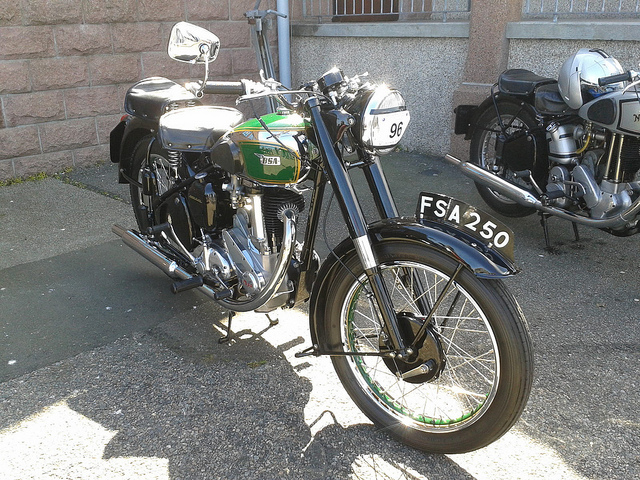Extract all visible text content from this image. FSA 250 96 